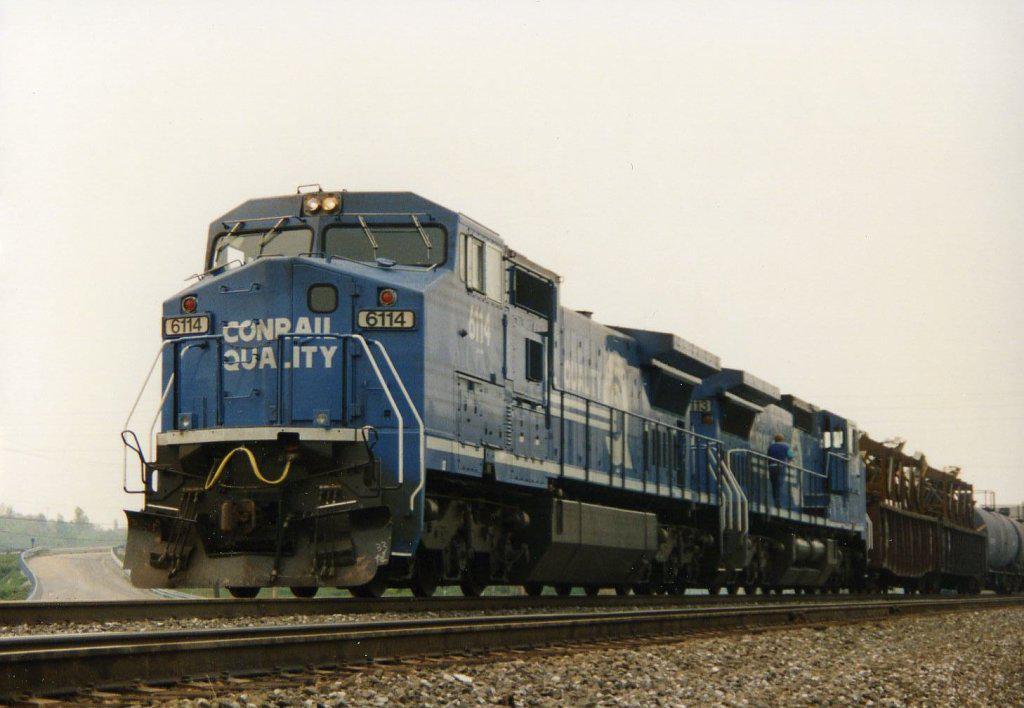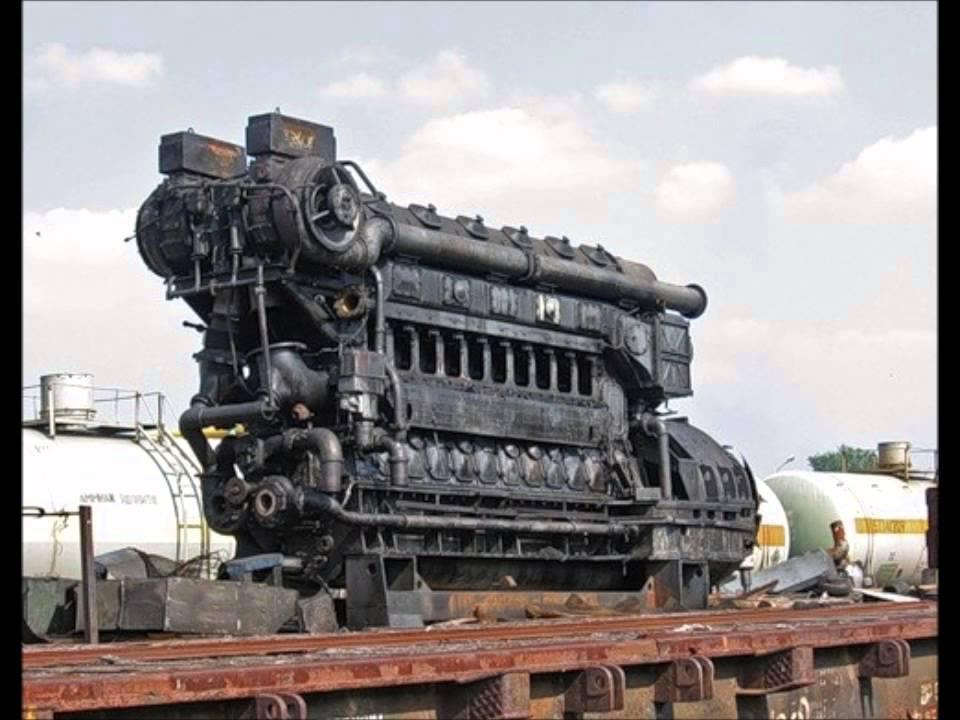The first image is the image on the left, the second image is the image on the right. For the images shown, is this caption "The image on the right contains a vehicle with black and white stripes." true? Answer yes or no. No. 